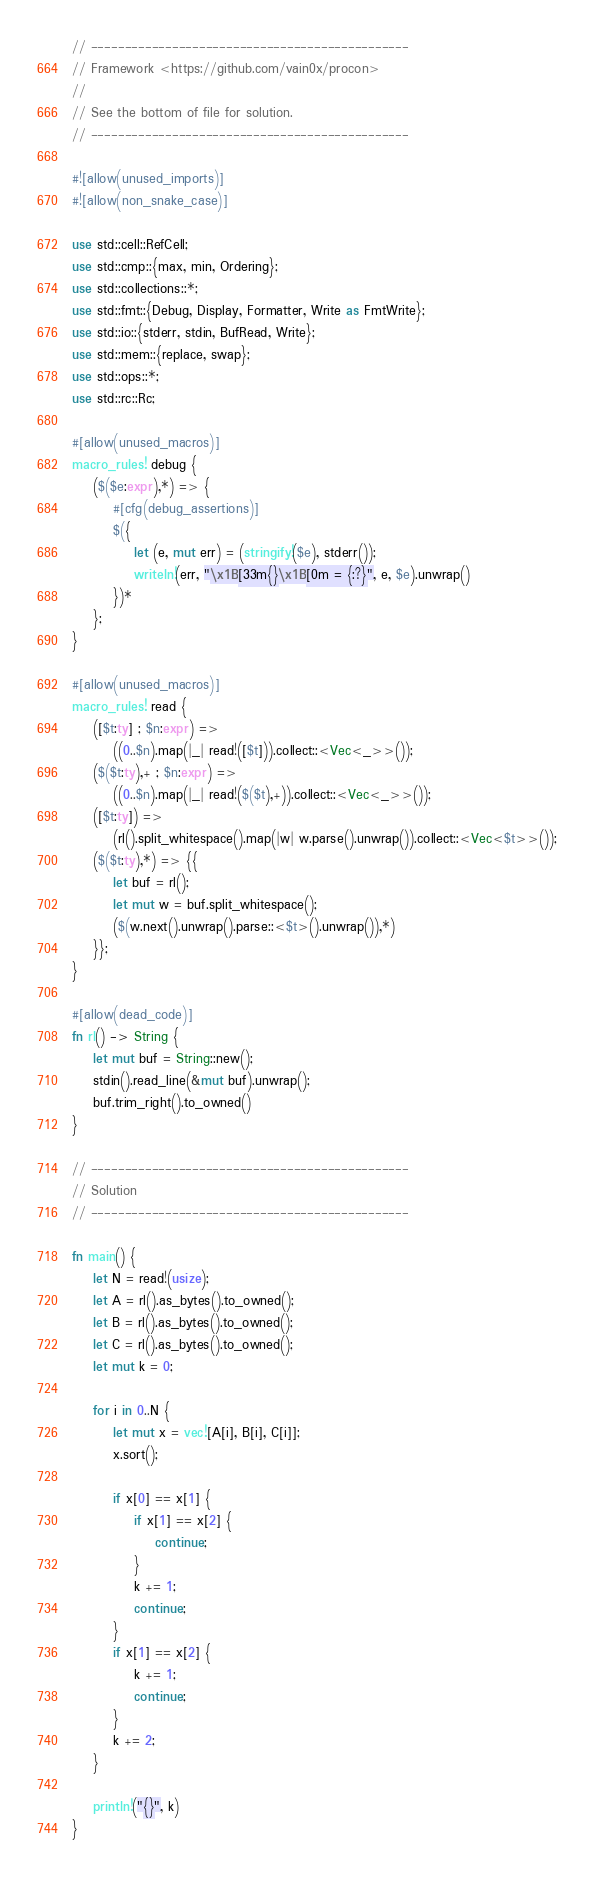Convert code to text. <code><loc_0><loc_0><loc_500><loc_500><_Rust_>// -----------------------------------------------
// Framework <https://github.com/vain0x/procon>
//
// See the bottom of file for solution.
// -----------------------------------------------

#![allow(unused_imports)]
#![allow(non_snake_case)]

use std::cell::RefCell;
use std::cmp::{max, min, Ordering};
use std::collections::*;
use std::fmt::{Debug, Display, Formatter, Write as FmtWrite};
use std::io::{stderr, stdin, BufRead, Write};
use std::mem::{replace, swap};
use std::ops::*;
use std::rc::Rc;

#[allow(unused_macros)]
macro_rules! debug {
    ($($e:expr),*) => {
        #[cfg(debug_assertions)]
        $({
            let (e, mut err) = (stringify!($e), stderr());
            writeln!(err, "\x1B[33m{}\x1B[0m = {:?}", e, $e).unwrap()
        })*
    };
}

#[allow(unused_macros)]
macro_rules! read {
    ([$t:ty] ; $n:expr) =>
        ((0..$n).map(|_| read!([$t])).collect::<Vec<_>>());
    ($($t:ty),+ ; $n:expr) =>
        ((0..$n).map(|_| read!($($t),+)).collect::<Vec<_>>());
    ([$t:ty]) =>
        (rl().split_whitespace().map(|w| w.parse().unwrap()).collect::<Vec<$t>>());
    ($($t:ty),*) => {{
        let buf = rl();
        let mut w = buf.split_whitespace();
        ($(w.next().unwrap().parse::<$t>().unwrap()),*)
    }};
}

#[allow(dead_code)]
fn rl() -> String {
    let mut buf = String::new();
    stdin().read_line(&mut buf).unwrap();
    buf.trim_right().to_owned()
}

// -----------------------------------------------
// Solution
// -----------------------------------------------

fn main() {
    let N = read!(usize);
    let A = rl().as_bytes().to_owned();
    let B = rl().as_bytes().to_owned();
    let C = rl().as_bytes().to_owned();
    let mut k = 0;

    for i in 0..N {
        let mut x = vec![A[i], B[i], C[i]];
        x.sort();

        if x[0] == x[1] {
            if x[1] == x[2] {
                continue;
            }
            k += 1;
            continue;
        }
        if x[1] == x[2] {
            k += 1;
            continue;
        }
        k += 2;
    }

    println!("{}", k)
}
</code> 